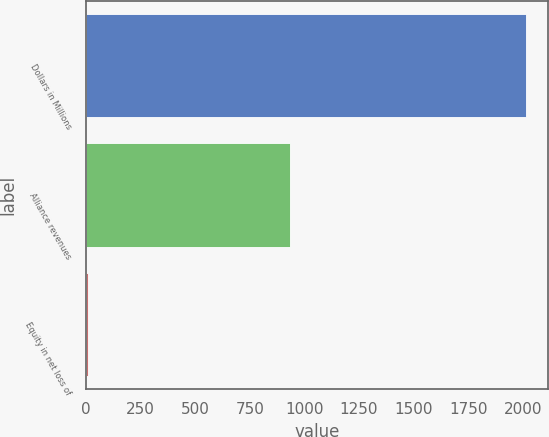Convert chart. <chart><loc_0><loc_0><loc_500><loc_500><bar_chart><fcel>Dollars in Millions<fcel>Alliance revenues<fcel>Equity in net loss of<nl><fcel>2016<fcel>934<fcel>12<nl></chart> 